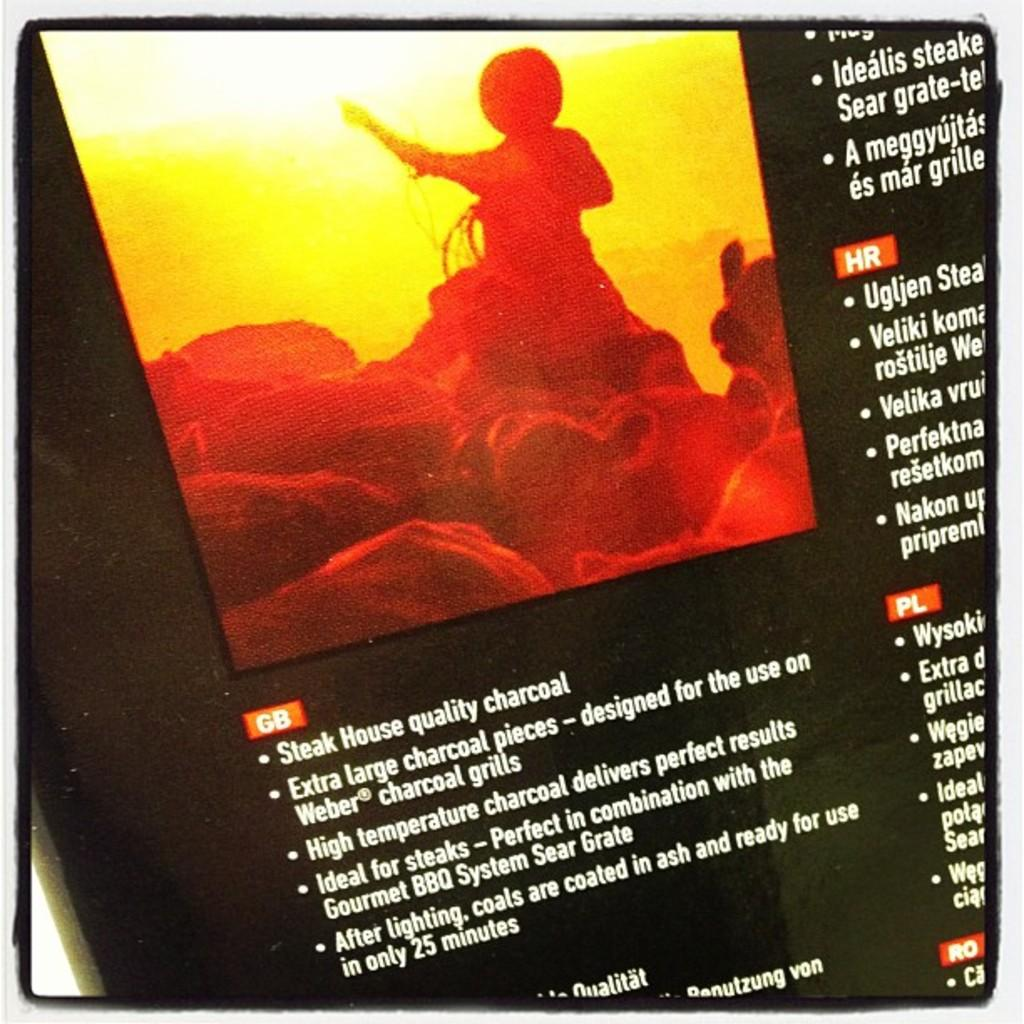Provide a one-sentence caption for the provided image. A advert for charcoal saying it is Steak House quality. 